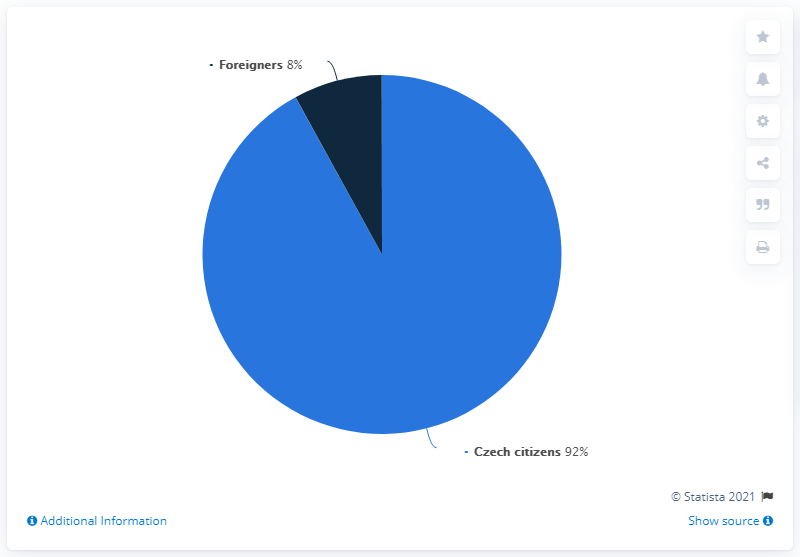List a handful of essential elements in this visual. The Czech citizens dominate the chart. The percentage of foreigners in the Czech Republic is lower than that of Czech citizens. 